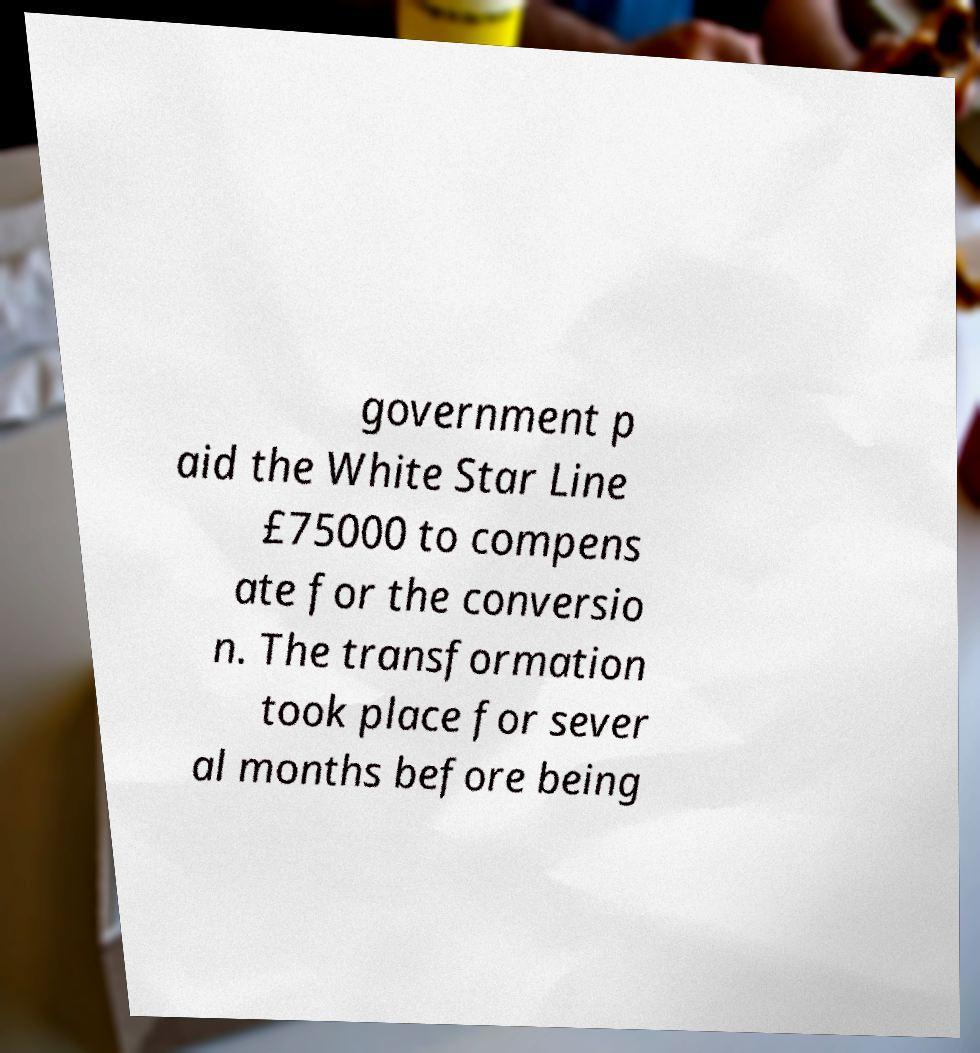For documentation purposes, I need the text within this image transcribed. Could you provide that? government p aid the White Star Line £75000 to compens ate for the conversio n. The transformation took place for sever al months before being 